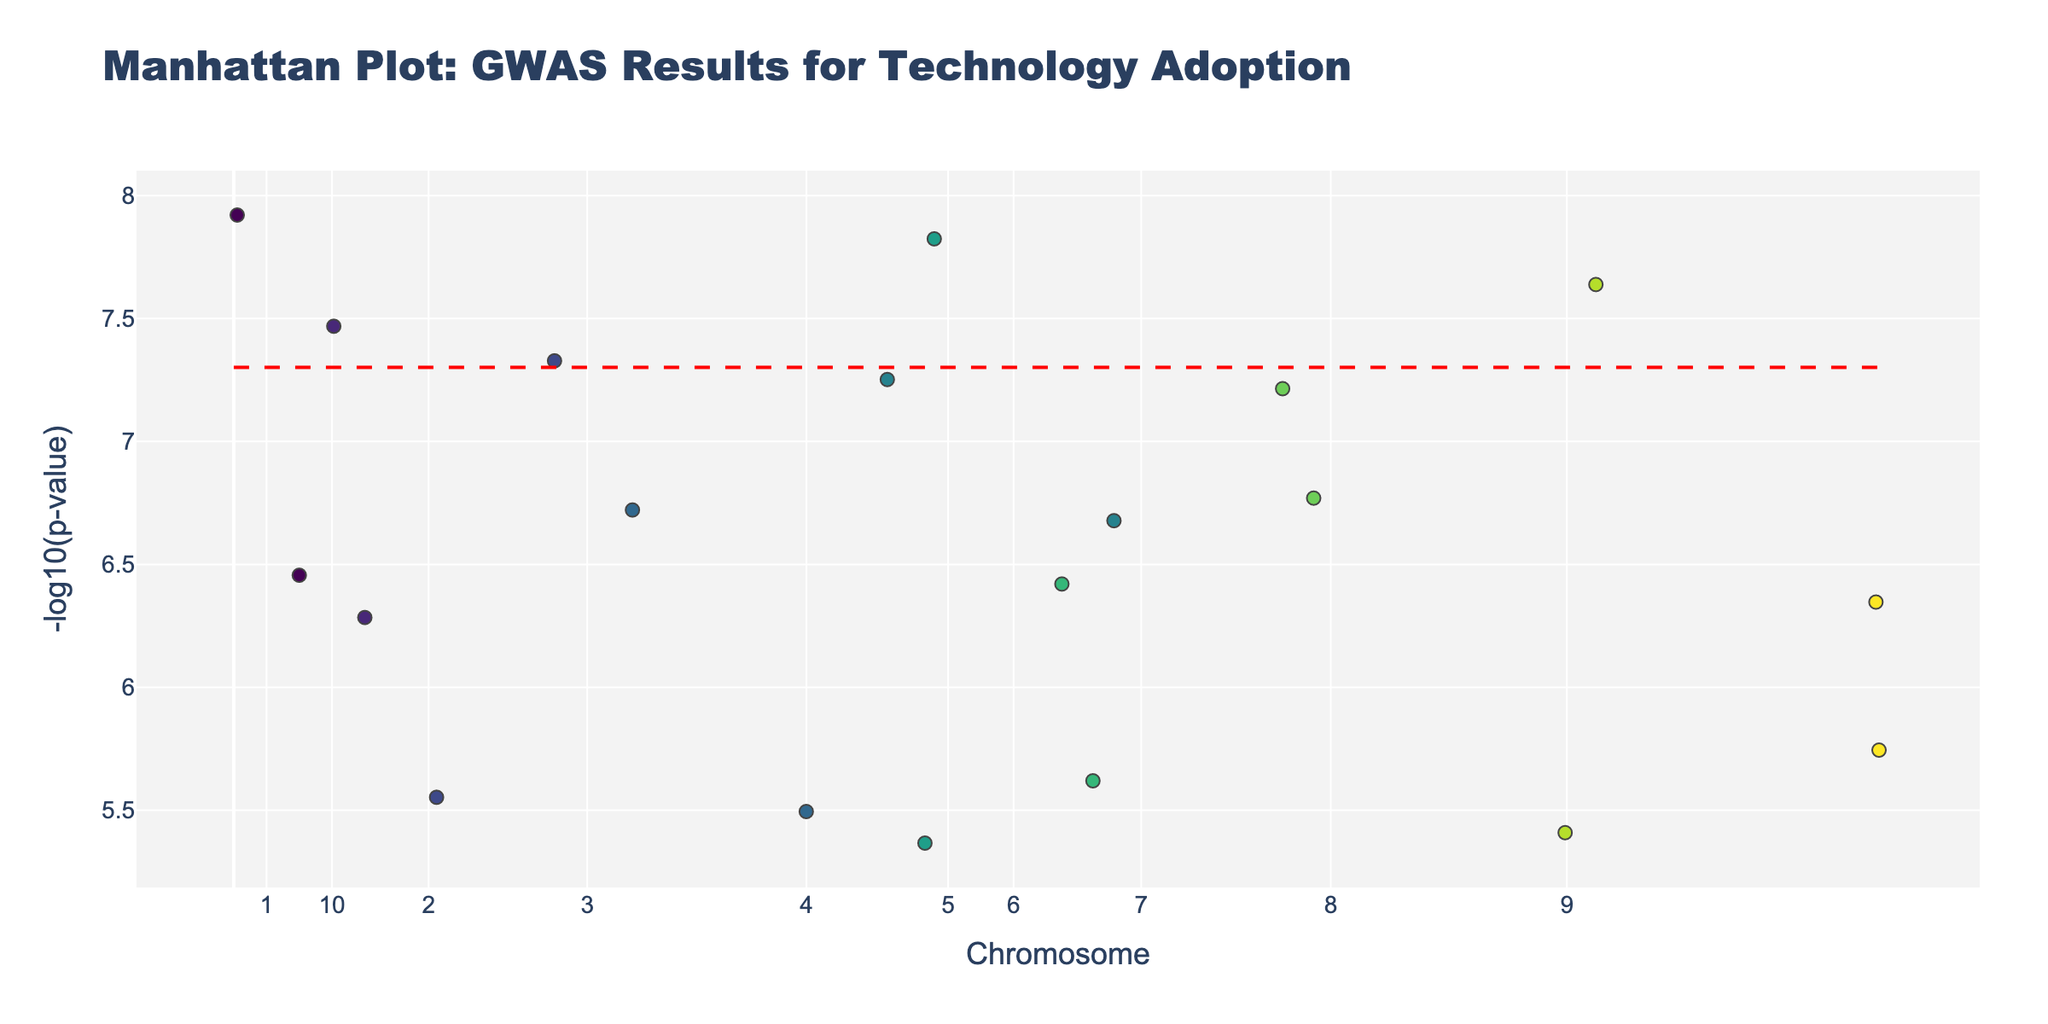What's the title of the plot? The title of the plot is clearly mentioned at the top of the Figure in a large and bold font.
Answer: Manhattan Plot: GWAS Results for Technology Adoption How is the x-axis labeled? The x-axis is labeled with tick values representing different chromosomes. Each tick value corresponds to the center of the chromosome's cumulative positions.
Answer: Chromosome What is the highest -log10(p-value) observed in the plot? Check the y-axis to determine the highest value reached by any data point in terms of -log10(p-value). This can be seen in the scatter points represented by their heights on the y-axis.
Answer: 8.92 Which trait has the lowest p-value? The trait with the lowest p-value will have the highest -log10(p-value). Identify the highest point on the y-axis and check the corresponding trait from the text shown upon hover.
Answer: Wearable tech adoption How many traits have -log10(p-value) values above 7? Count the data points that cross the threshold of 7 on the y-axis to determine how many traits have -log10(p-value) values exceeding this level.
Answer: 5 Is there a significant p-value threshold indicated in the plot? Yes, look for any horizontal line within the plot that represents a threshold for significance, annotated typically in red dash. This line indicates where traits become statistically significant.
Answer: Yes, at -log10(5e-8) Which chromosomes have traits that exceed the significance threshold? Identify all the chromosomes where data points cross the red dashed significance line. Notate the Chromosome labels from the x-axis that align with these points.
Answer: Chromosomes 1, 4, 6, 7, 10 What trait on Chromosome 7 has the highest -log10(p-value)? Look specifically at the data points on Chromosome 7 and identify which of them has the highest y-axis value. Check the corresponding trait displayed with hover text.
Answer: Virtual reality experience Among traits with p-values less than 1e-6, which trait belongs to Chromosome 5? Examine the y-axis positions that represent -log10(p-value) > 6 and locate which of these is placed within Chromosome 5 on x-axis. Based on hover text information, identify the trait.
Answer: Cybersecurity awareness What color scheme is used for different chromosomes, and how can it be interpreted? A Viridis colorscale is employed to denote different chromosomes. Each chromosome's data points are uniquely colored, allowing for visual differentiation.
Answer: Viridis colorscale Is there a clustering of traits around specific chromosomes, and what might that indicate? Assess the distribution of data points along the x-axis; tightly packed clusters around specific chromosomes may indicate a concentration of significant genetic associations for certain traits.
Answer: Yes, it may indicate significant genetic associations 